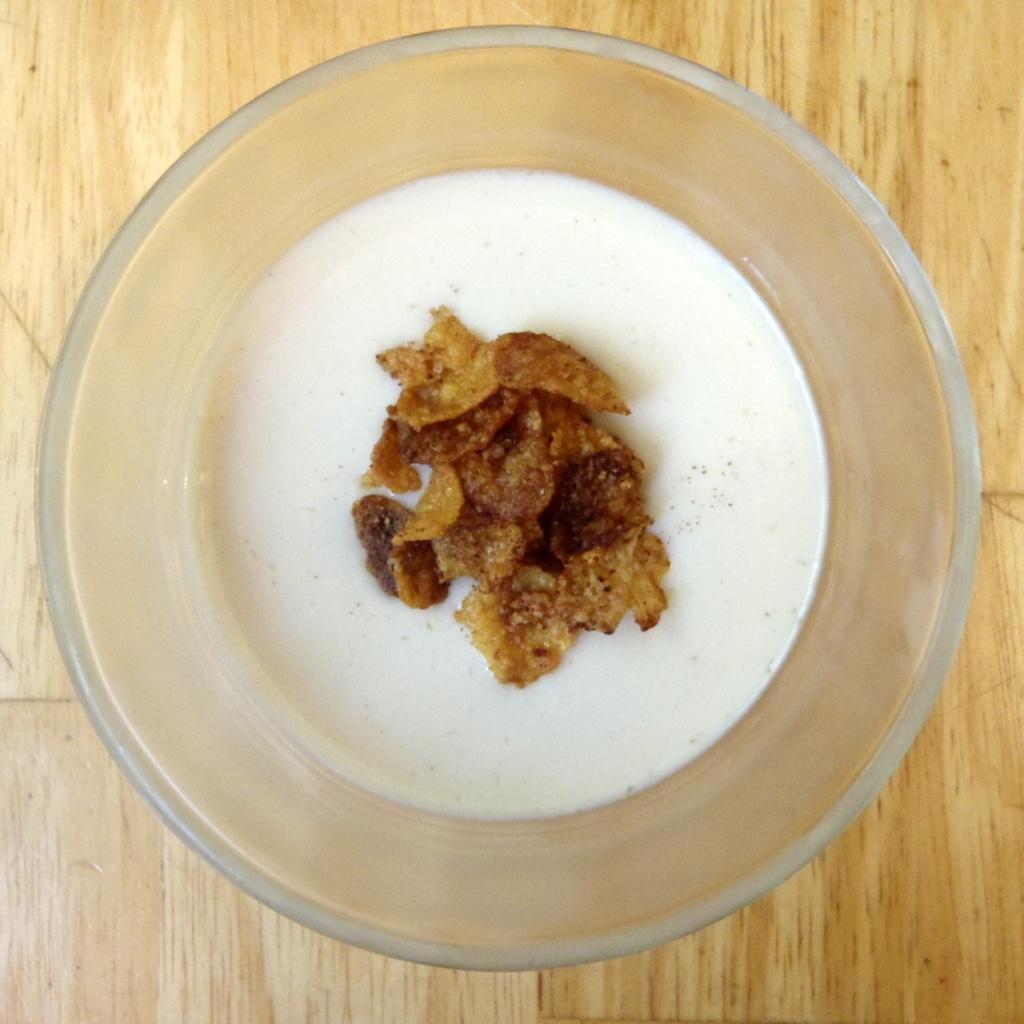What is present in the image that can hold food? There is a bowl in the image that can hold food. What type of food is in the bowl? There is food in the bowl, but the specific type is not mentioned in the facts. Where is the bowl located in the image? The bowl is placed on a table in the image. How many coats are hanging on the wall in the image? There is no information about coats or a wall in the image, so we cannot answer this question. 